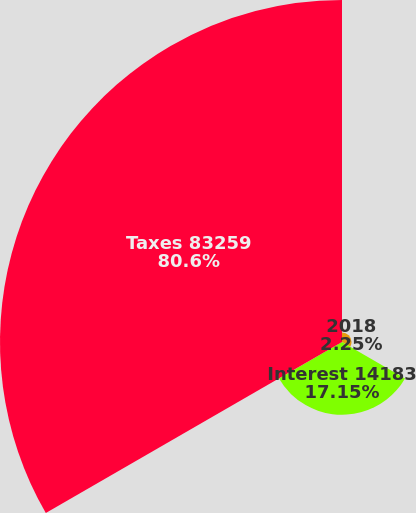Convert chart. <chart><loc_0><loc_0><loc_500><loc_500><pie_chart><fcel>2018<fcel>Interest 14183<fcel>Taxes 83259<nl><fcel>2.25%<fcel>17.15%<fcel>80.6%<nl></chart> 